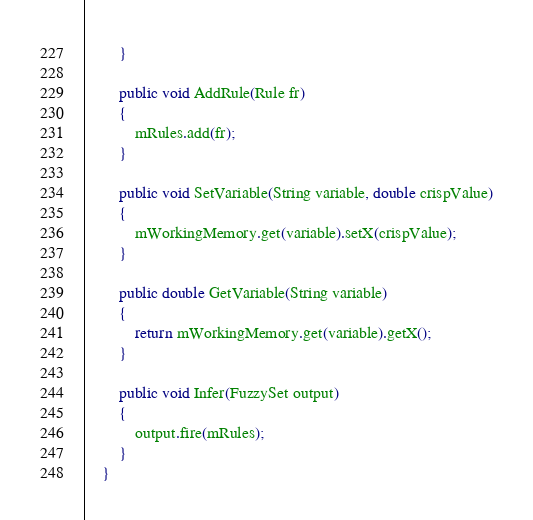Convert code to text. <code><loc_0><loc_0><loc_500><loc_500><_Java_>
        }

        public void AddRule(Rule fr)
        {
            mRules.add(fr);
        }

        public void SetVariable(String variable, double crispValue)
        {
            mWorkingMemory.get(variable).setX(crispValue);
        }

        public double GetVariable(String variable)
        {
            return mWorkingMemory.get(variable).getX();
        }

        public void Infer(FuzzySet output)
        {
            output.fire(mRules);
        }
    }
</code> 